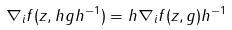Convert formula to latex. <formula><loc_0><loc_0><loc_500><loc_500>\nabla _ { i } f ( z , h g h ^ { - 1 } ) = h \nabla _ { i } f ( z , g ) h ^ { - 1 }</formula> 